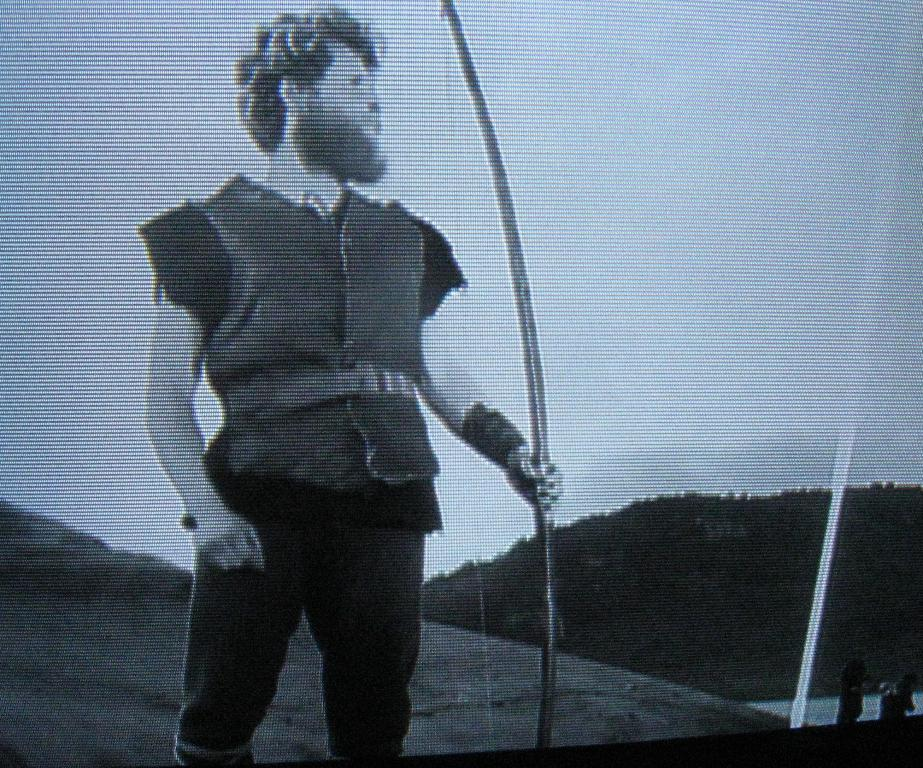What is the color scheme of the image? The image is black and white. Who or what is the main subject of the image? There is a person in the image. What is the person holding in his hand? The person is holding a bow in his hand. What can be seen in the background of the image? There is a mountain and the sky visible in the background of the image. How much payment is being exchanged between the person and the mountain in the image? There is no payment being exchanged in the image; it is a person holding a bow in front of a mountain and the sky. What type of planes can be seen flying in the image? There are no planes visible in the image; it features a person holding a bow in front of a mountain and the sky. 